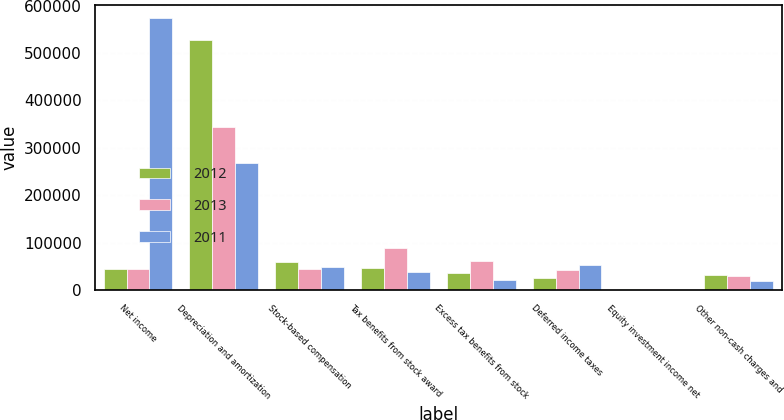Convert chart. <chart><loc_0><loc_0><loc_500><loc_500><stacked_bar_chart><ecel><fcel>Net income<fcel>Depreciation and amortization<fcel>Stock-based compensation<fcel>Tax benefits from stock award<fcel>Excess tax benefits from stock<fcel>Deferred income taxes<fcel>Equity investment income net<fcel>Other non-cash charges and<nl><fcel>2012<fcel>44574.5<fcel>528119<fcel>59998<fcel>46898<fcel>36197<fcel>25380<fcel>2872<fcel>31351<nl><fcel>2013<fcel>44574.5<fcel>343908<fcel>45384<fcel>88964<fcel>62036<fcel>43765<fcel>3384<fcel>30390<nl><fcel>2011<fcel>573395<fcel>267315<fcel>48718<fcel>38199<fcel>20834<fcel>53438<fcel>354<fcel>20329<nl></chart> 